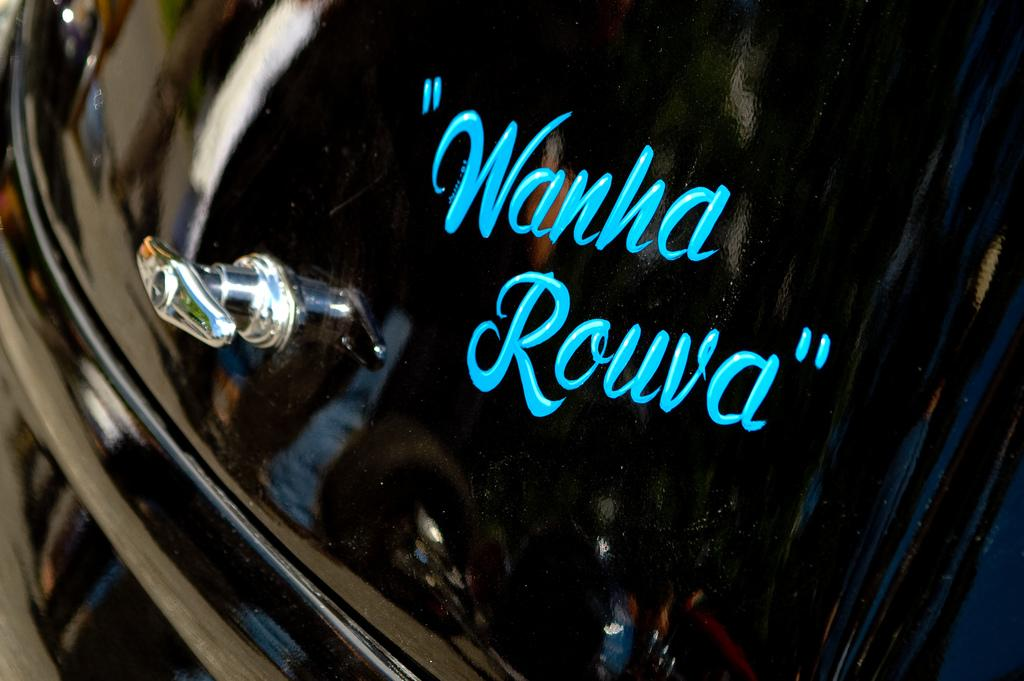What is the main subject of the image? The main subject of the image is words written on a vehicle. Can you describe the vehicle in the image? Unfortunately, the provided facts do not give any information about the vehicle itself, only that there are words written on it. What type of hat is the person wearing while writing the words on the vehicle? There is no person or hat present in the image; it only features words written on a vehicle. 